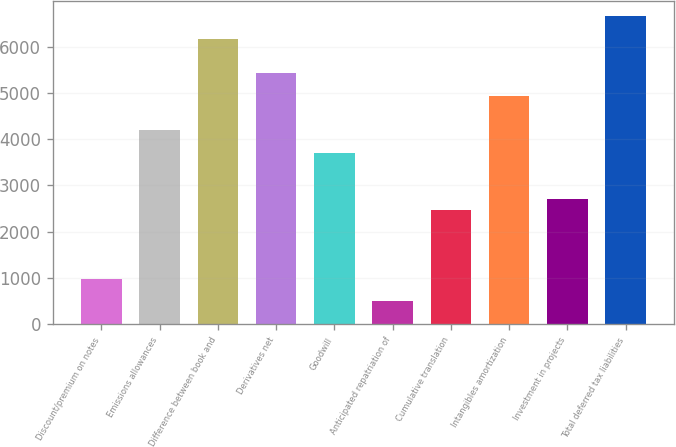Convert chart to OTSL. <chart><loc_0><loc_0><loc_500><loc_500><bar_chart><fcel>Discount/premium on notes<fcel>Emissions allowances<fcel>Difference between book and<fcel>Derivatives net<fcel>Goodwill<fcel>Anticipated repatriation of<fcel>Cumulative translation<fcel>Intangibles amortization<fcel>Investment in projects<fcel>Total deferred tax liabilities<nl><fcel>986.6<fcel>4189.8<fcel>6161<fcel>5421.8<fcel>3697<fcel>493.8<fcel>2465<fcel>4929<fcel>2711.4<fcel>6653.8<nl></chart> 